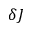Convert formula to latex. <formula><loc_0><loc_0><loc_500><loc_500>\delta J</formula> 